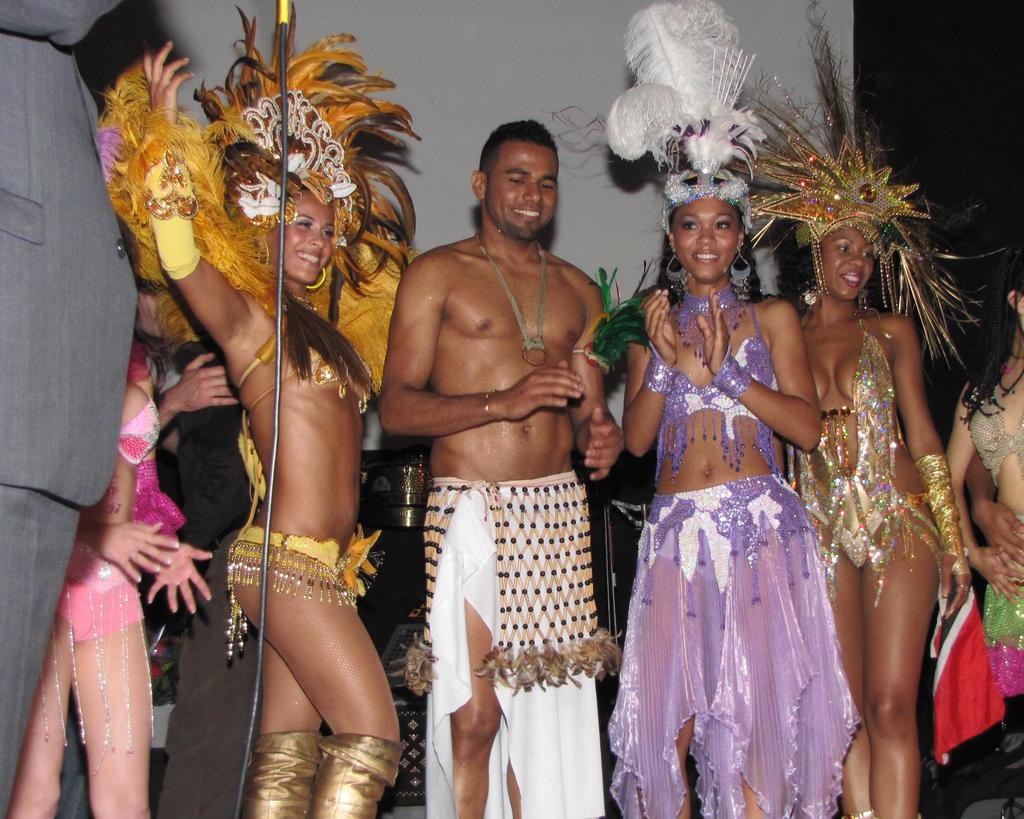How many people are in the image? There is a group of people in the image. What are the people wearing? The people are wearing costumes. What is the color scheme of the background in the image? The background of the image is white and black. Can you tell me how many goats are in the image? There are no goats present in the image; it features a group of people wearing costumes. What type of profit can be seen in the image? There is no mention of profit in the image; it only shows a group of people wearing costumes with a white and black background. 